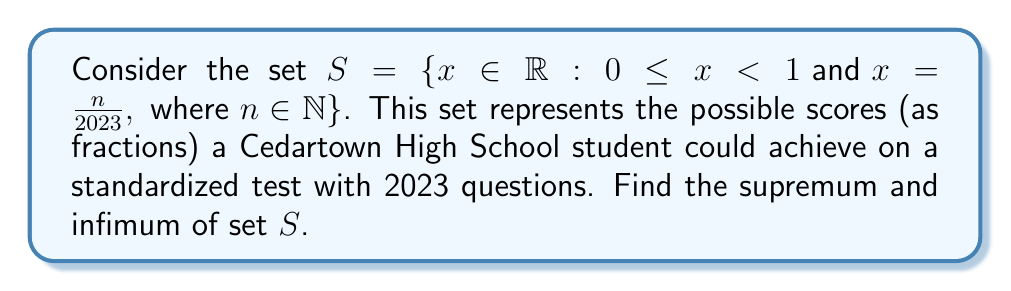Can you answer this question? To find the supremum and infimum of set $S$, let's analyze its properties:

1) First, we need to understand what the set contains:
   $S = \{0, \frac{1}{2023}, \frac{2}{2023}, \frac{3}{2023}, ..., \frac{2022}{2023}\}$

2) Infimum (greatest lower bound):
   - The smallest element in the set is 0.
   - There is no element in $\mathbb{R}$ that is smaller than 0 and still a lower bound for $S$.
   - Therefore, $\inf(S) = 0$

3) Supremum (least upper bound):
   - The largest element in the set is $\frac{2022}{2023}$.
   - Any number greater than or equal to $\frac{2022}{2023}$ but less than 1 is an upper bound.
   - The smallest such upper bound is $\frac{2022}{2023}$.
   - Therefore, $\sup(S) = \frac{2022}{2023}$

4) Note that 1 is not in the set because of the strict inequality in the set definition $(x < 1)$.

5) We can verify that $\frac{2022}{2023}$ is indeed the largest element:
   $$\frac{2022}{2023} = 1 - \frac{1}{2023} \approx 0.9995$$
   This is the closest fraction to 1 with denominator 2023.
Answer: $\inf(S) = 0$ and $\sup(S) = \frac{2022}{2023}$ 